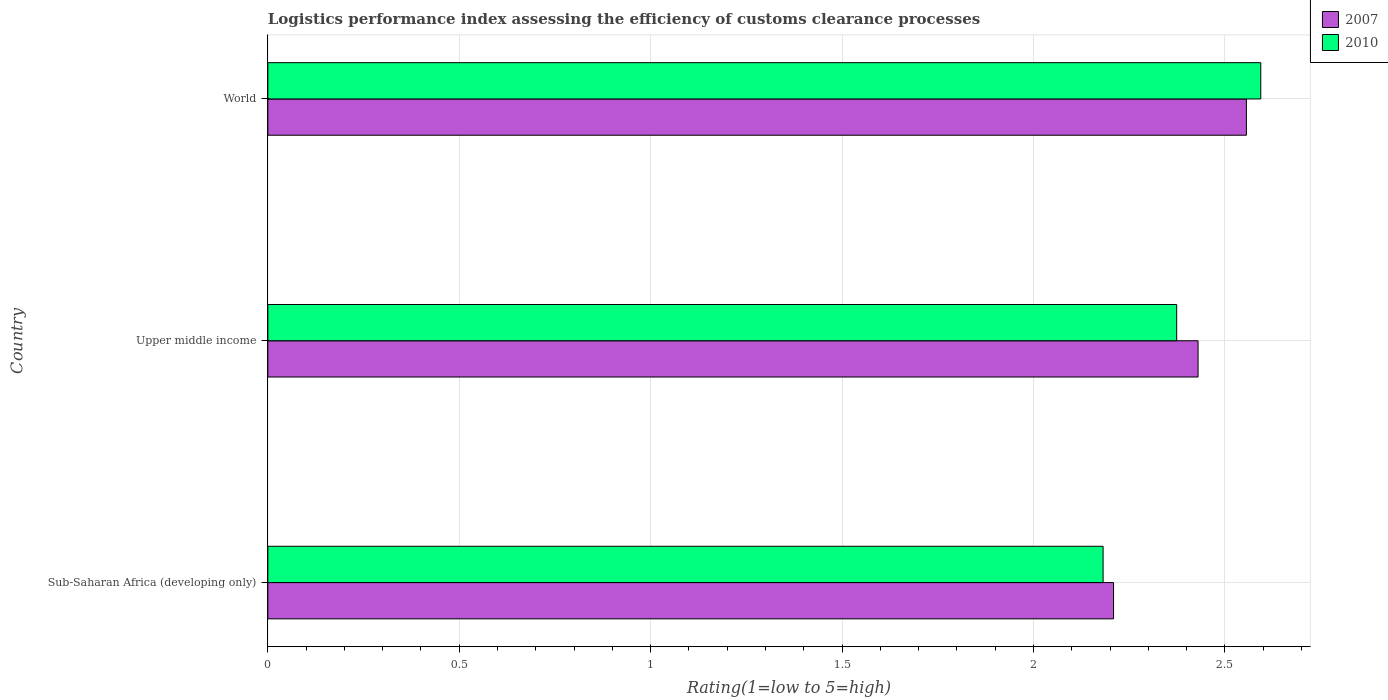How many different coloured bars are there?
Make the answer very short. 2. How many groups of bars are there?
Make the answer very short. 3. How many bars are there on the 3rd tick from the top?
Provide a succinct answer. 2. What is the label of the 3rd group of bars from the top?
Offer a terse response. Sub-Saharan Africa (developing only). What is the Logistic performance index in 2010 in Sub-Saharan Africa (developing only)?
Keep it short and to the point. 2.18. Across all countries, what is the maximum Logistic performance index in 2010?
Your answer should be very brief. 2.59. Across all countries, what is the minimum Logistic performance index in 2010?
Keep it short and to the point. 2.18. In which country was the Logistic performance index in 2007 maximum?
Your answer should be very brief. World. In which country was the Logistic performance index in 2010 minimum?
Keep it short and to the point. Sub-Saharan Africa (developing only). What is the total Logistic performance index in 2010 in the graph?
Your response must be concise. 7.15. What is the difference between the Logistic performance index in 2010 in Upper middle income and that in World?
Offer a terse response. -0.22. What is the difference between the Logistic performance index in 2010 in Sub-Saharan Africa (developing only) and the Logistic performance index in 2007 in World?
Your answer should be very brief. -0.37. What is the average Logistic performance index in 2007 per country?
Provide a succinct answer. 2.4. What is the difference between the Logistic performance index in 2007 and Logistic performance index in 2010 in World?
Make the answer very short. -0.04. What is the ratio of the Logistic performance index in 2007 in Upper middle income to that in World?
Provide a succinct answer. 0.95. Is the Logistic performance index in 2007 in Sub-Saharan Africa (developing only) less than that in Upper middle income?
Provide a short and direct response. Yes. What is the difference between the highest and the second highest Logistic performance index in 2010?
Offer a very short reply. 0.22. What is the difference between the highest and the lowest Logistic performance index in 2010?
Make the answer very short. 0.41. In how many countries, is the Logistic performance index in 2010 greater than the average Logistic performance index in 2010 taken over all countries?
Give a very brief answer. 1. Is the sum of the Logistic performance index in 2007 in Sub-Saharan Africa (developing only) and Upper middle income greater than the maximum Logistic performance index in 2010 across all countries?
Your answer should be compact. Yes. How many bars are there?
Your answer should be compact. 6. Are the values on the major ticks of X-axis written in scientific E-notation?
Your answer should be very brief. No. Does the graph contain any zero values?
Your answer should be compact. No. Where does the legend appear in the graph?
Provide a short and direct response. Top right. How many legend labels are there?
Offer a terse response. 2. How are the legend labels stacked?
Your answer should be very brief. Vertical. What is the title of the graph?
Your answer should be compact. Logistics performance index assessing the efficiency of customs clearance processes. What is the label or title of the X-axis?
Offer a very short reply. Rating(1=low to 5=high). What is the Rating(1=low to 5=high) in 2007 in Sub-Saharan Africa (developing only)?
Make the answer very short. 2.21. What is the Rating(1=low to 5=high) in 2010 in Sub-Saharan Africa (developing only)?
Offer a terse response. 2.18. What is the Rating(1=low to 5=high) of 2007 in Upper middle income?
Give a very brief answer. 2.43. What is the Rating(1=low to 5=high) of 2010 in Upper middle income?
Offer a terse response. 2.37. What is the Rating(1=low to 5=high) in 2007 in World?
Ensure brevity in your answer.  2.56. What is the Rating(1=low to 5=high) of 2010 in World?
Ensure brevity in your answer.  2.59. Across all countries, what is the maximum Rating(1=low to 5=high) of 2007?
Offer a very short reply. 2.56. Across all countries, what is the maximum Rating(1=low to 5=high) in 2010?
Make the answer very short. 2.59. Across all countries, what is the minimum Rating(1=low to 5=high) of 2007?
Keep it short and to the point. 2.21. Across all countries, what is the minimum Rating(1=low to 5=high) of 2010?
Offer a very short reply. 2.18. What is the total Rating(1=low to 5=high) in 2007 in the graph?
Make the answer very short. 7.19. What is the total Rating(1=low to 5=high) in 2010 in the graph?
Offer a terse response. 7.15. What is the difference between the Rating(1=low to 5=high) in 2007 in Sub-Saharan Africa (developing only) and that in Upper middle income?
Ensure brevity in your answer.  -0.22. What is the difference between the Rating(1=low to 5=high) in 2010 in Sub-Saharan Africa (developing only) and that in Upper middle income?
Your answer should be very brief. -0.19. What is the difference between the Rating(1=low to 5=high) in 2007 in Sub-Saharan Africa (developing only) and that in World?
Offer a terse response. -0.35. What is the difference between the Rating(1=low to 5=high) of 2010 in Sub-Saharan Africa (developing only) and that in World?
Ensure brevity in your answer.  -0.41. What is the difference between the Rating(1=low to 5=high) of 2007 in Upper middle income and that in World?
Offer a terse response. -0.13. What is the difference between the Rating(1=low to 5=high) of 2010 in Upper middle income and that in World?
Make the answer very short. -0.22. What is the difference between the Rating(1=low to 5=high) in 2007 in Sub-Saharan Africa (developing only) and the Rating(1=low to 5=high) in 2010 in Upper middle income?
Your answer should be very brief. -0.16. What is the difference between the Rating(1=low to 5=high) in 2007 in Sub-Saharan Africa (developing only) and the Rating(1=low to 5=high) in 2010 in World?
Offer a terse response. -0.38. What is the difference between the Rating(1=low to 5=high) of 2007 in Upper middle income and the Rating(1=low to 5=high) of 2010 in World?
Provide a succinct answer. -0.16. What is the average Rating(1=low to 5=high) of 2007 per country?
Ensure brevity in your answer.  2.4. What is the average Rating(1=low to 5=high) of 2010 per country?
Make the answer very short. 2.38. What is the difference between the Rating(1=low to 5=high) of 2007 and Rating(1=low to 5=high) of 2010 in Sub-Saharan Africa (developing only)?
Provide a succinct answer. 0.03. What is the difference between the Rating(1=low to 5=high) of 2007 and Rating(1=low to 5=high) of 2010 in Upper middle income?
Offer a very short reply. 0.06. What is the difference between the Rating(1=low to 5=high) of 2007 and Rating(1=low to 5=high) of 2010 in World?
Offer a very short reply. -0.04. What is the ratio of the Rating(1=low to 5=high) of 2007 in Sub-Saharan Africa (developing only) to that in Upper middle income?
Your answer should be very brief. 0.91. What is the ratio of the Rating(1=low to 5=high) of 2010 in Sub-Saharan Africa (developing only) to that in Upper middle income?
Provide a short and direct response. 0.92. What is the ratio of the Rating(1=low to 5=high) of 2007 in Sub-Saharan Africa (developing only) to that in World?
Your answer should be compact. 0.86. What is the ratio of the Rating(1=low to 5=high) of 2010 in Sub-Saharan Africa (developing only) to that in World?
Offer a very short reply. 0.84. What is the ratio of the Rating(1=low to 5=high) in 2007 in Upper middle income to that in World?
Offer a terse response. 0.95. What is the ratio of the Rating(1=low to 5=high) in 2010 in Upper middle income to that in World?
Ensure brevity in your answer.  0.92. What is the difference between the highest and the second highest Rating(1=low to 5=high) in 2007?
Your answer should be compact. 0.13. What is the difference between the highest and the second highest Rating(1=low to 5=high) of 2010?
Provide a short and direct response. 0.22. What is the difference between the highest and the lowest Rating(1=low to 5=high) of 2007?
Provide a short and direct response. 0.35. What is the difference between the highest and the lowest Rating(1=low to 5=high) of 2010?
Offer a very short reply. 0.41. 